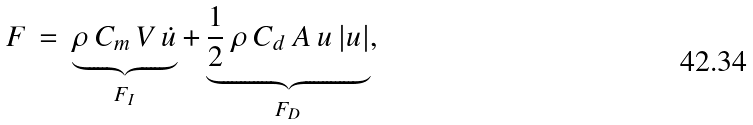<formula> <loc_0><loc_0><loc_500><loc_500>F \, = \, \underbrace { \rho \, C _ { m } \, V \, { \dot { u } } } _ { F _ { I } } + \underbrace { { \frac { 1 } { 2 } } \, \rho \, C _ { d } \, A \, u \, | u | } _ { F _ { D } } ,</formula> 